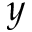Convert formula to latex. <formula><loc_0><loc_0><loc_500><loc_500>y</formula> 